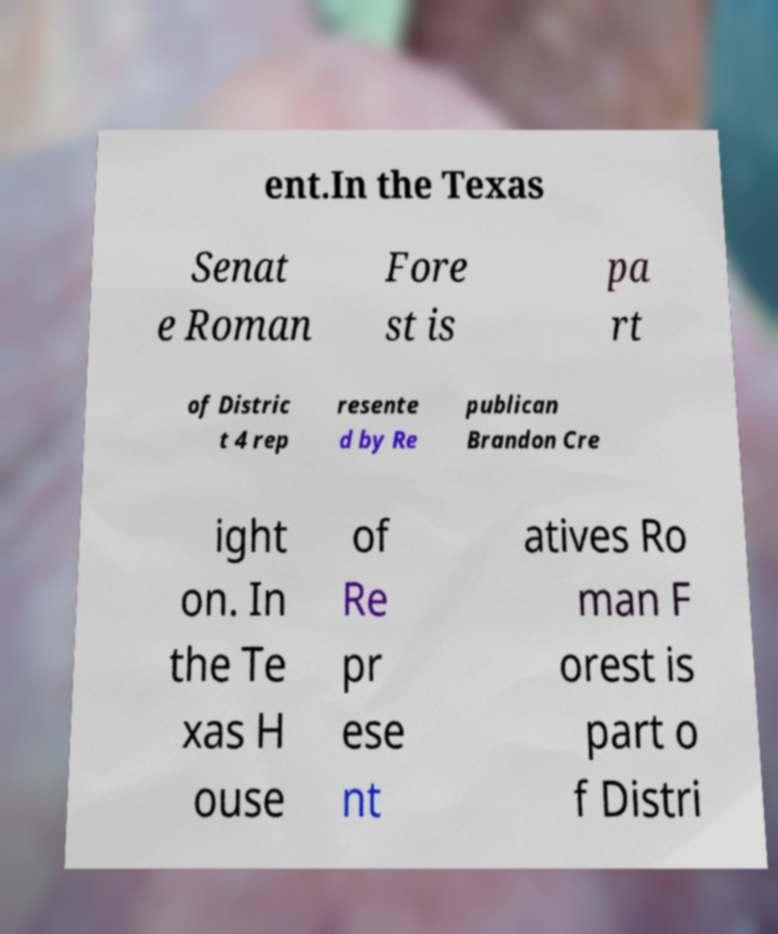I need the written content from this picture converted into text. Can you do that? ent.In the Texas Senat e Roman Fore st is pa rt of Distric t 4 rep resente d by Re publican Brandon Cre ight on. In the Te xas H ouse of Re pr ese nt atives Ro man F orest is part o f Distri 